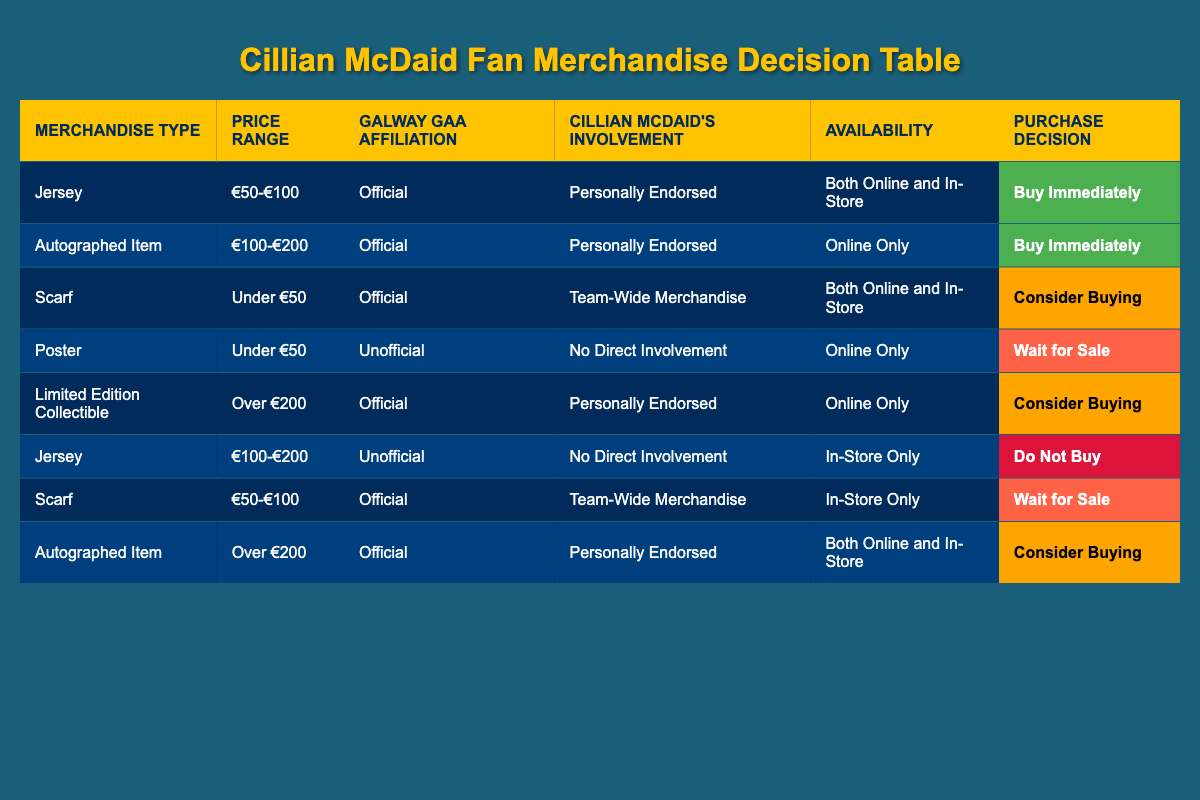What type of merchandise has the highest purchase decision? The merchandise types with the highest purchase decisions are "Jersey" and "Autographed Item," both with "Buy Immediately" as the action. Both items are also affiliated with Galway GAA officially and personally endorsed by Cillian McDaid.
Answer: Jersey and Autographed Item Is there any item that will lead to a purchase decision of "Do Not Buy"? Yes, there is one item listed as "Jersey" under the conditions of "€100-€200", "Unofficial", "No Direct Involvement", and "In-Store Only" which results in the decision to "Do Not Buy".
Answer: Yes What is the price range for the merchandise that is available online only and involves no direct involvement from Cillian McDaid? The only merchandise available online only with no direct involvement is the "Poster," priced under €50. This is confirmed by checking the "Availability" and "Cillian McDaid's Involvement" columns for the respective rows.
Answer: Under €50 How many merchandise types can lead to a purchase decision of "Consider Buying"? There are three merchandise types that can lead to a "Consider Buying" decision: "Scarf" (Under €50, Official, Team-Wide Merchandise, In-Store Only), "Limited Edition Collectible" (Over €200, Official, Personally Endorsed, Online Only), and "Autographed Item" (Over €200, Official, Personally Endorsed, Both Online and In-Store). They all fulfill the criteria for consideration respectively.
Answer: Three Are all jerseys affiliated with "Unofficial" classified as "Do Not Buy"? No, not all jerseys affiliated with "Unofficial" are classified as "Do Not Buy". Only the specific case of "Jersey" priced between €100-€200 with "No Direct Involvement" and "In-Store Only" results in "Do Not Buy". There is no mention of jerseys at other price points affecting the decision similarly.
Answer: No 